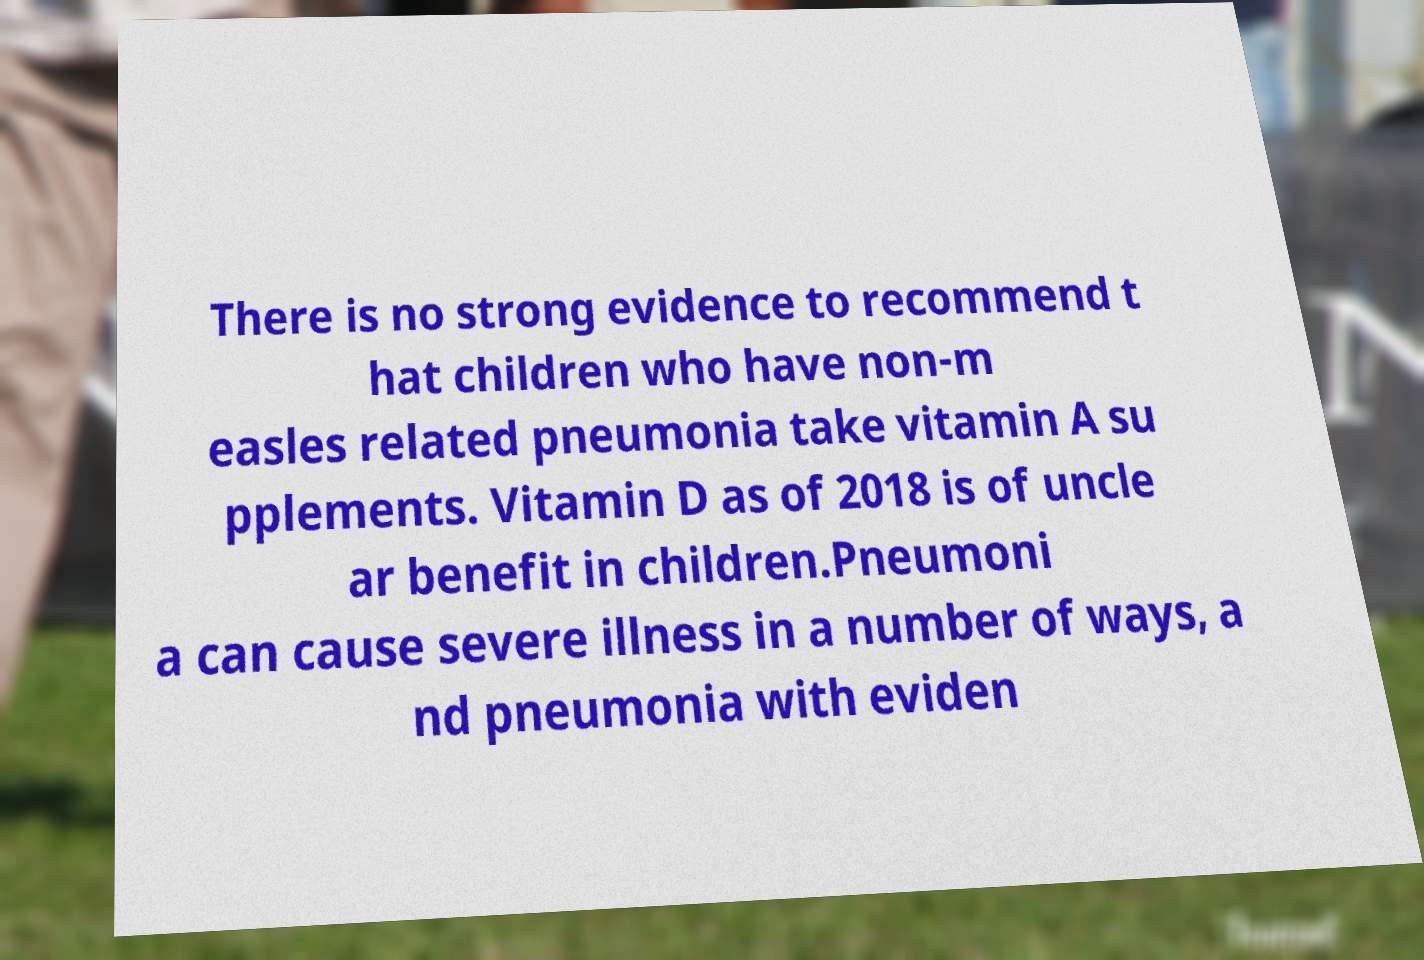There's text embedded in this image that I need extracted. Can you transcribe it verbatim? There is no strong evidence to recommend t hat children who have non-m easles related pneumonia take vitamin A su pplements. Vitamin D as of 2018 is of uncle ar benefit in children.Pneumoni a can cause severe illness in a number of ways, a nd pneumonia with eviden 